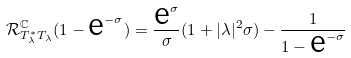Convert formula to latex. <formula><loc_0><loc_0><loc_500><loc_500>\mathcal { R } ^ { \mathbb { C } } _ { T ^ { * } _ { \lambda } T _ { \lambda } } ( 1 - \text {e} ^ { - \sigma } ) = \frac { \text {e} ^ { \sigma } } { \sigma } ( 1 + | \lambda | ^ { 2 } \sigma ) - \frac { 1 } { 1 - \text {e} ^ { - \sigma } }</formula> 